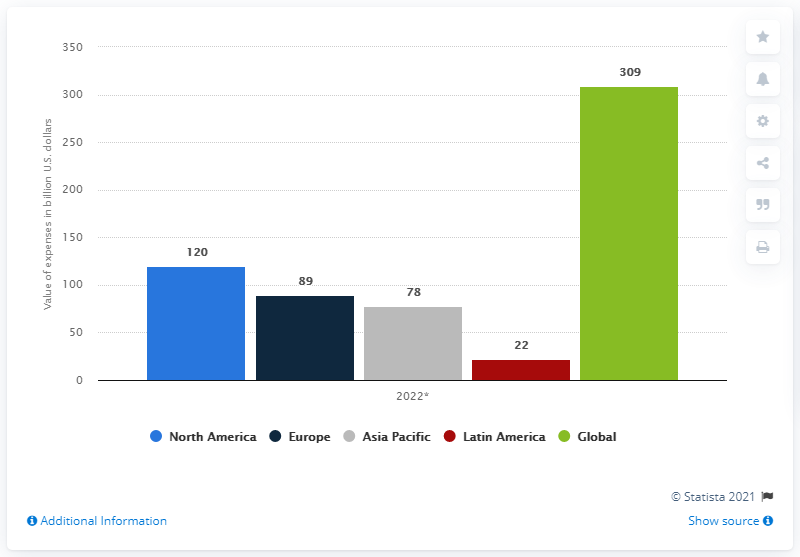Point out several critical features in this image. The expenses for global appear to be the highest among the options provided. It is projected that banks in North America will spend $120 million on IT in 2022. According to the information available, in 2022, the global total of expenditures by banks on IT was approximately 309 billion US dollars. The difference between the highest and lowest projected expense for the month of May is $287. 